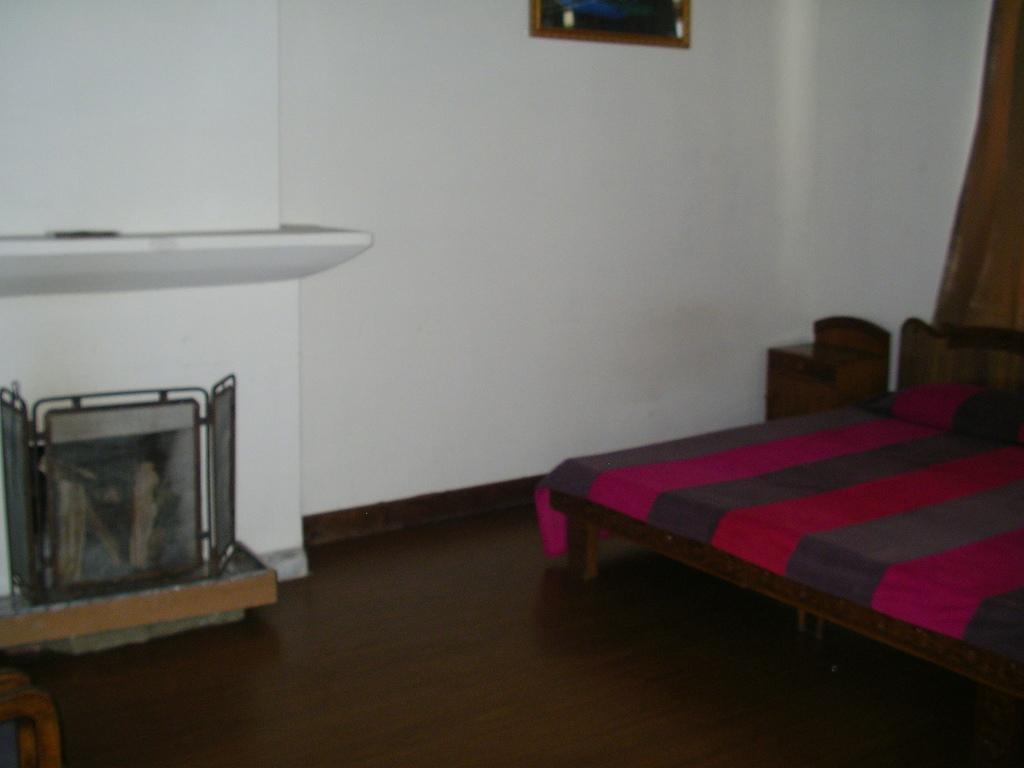What type of furniture is present in the image? There is a bed in the picture. What can be seen on the wall in the image? There is a frame on the wall. What is located on the floor in the image? There is an object placed on the floor. What type of garden can be seen through the window in the image? There is no window or garden present in the image; it only features a bed, a frame on the wall, and an object on the floor. What type of punishment is being depicted in the image? There is no punishment being depicted in the image; it only features a bed, a frame on the wall, and an object on the floor. 